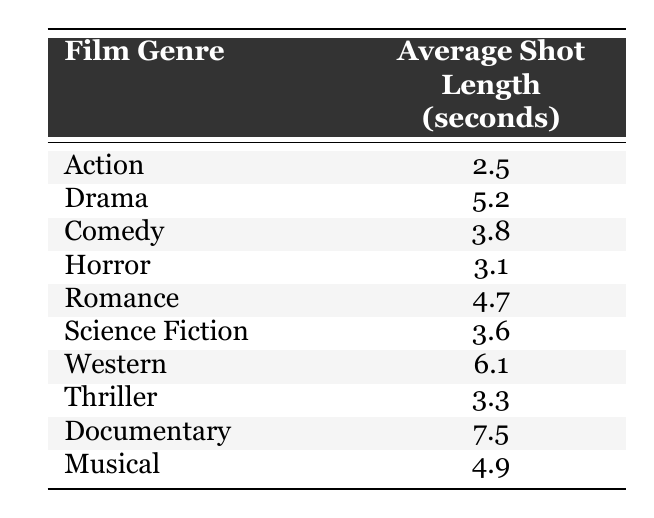What is the average shot length for the Action genre? The table lists Action with an average shot length of 2.5 seconds. This is a direct retrieval of the value from the table.
Answer: 2.5 Which film genre has the longest average shot length? The table indicates that the Documentary genre has the longest average shot length at 7.5 seconds. This can be found by comparing all the values in the second column to find the maximum.
Answer: 7.5 Is the average shot length for Comedy longer than that for Horror? The table shows that Comedy has an average shot length of 3.8 seconds while Horror has 3.1 seconds. Since 3.8 is greater than 3.1, the statement is true.
Answer: Yes What is the average shot length of the Romance and Science Fiction genres combined? To find the combined average, we first sum the average shot lengths for both genres: 4.7 (Romance) + 3.6 (Science Fiction) = 8.3 seconds. There are 2 genres, so we divide the sum by 2: 8.3/2 = 4.15 seconds.
Answer: 4.15 Is it true that the Thriller genre has an average shot length shorter than 4 seconds? The table states that the average shot length for Thriller is 3.3 seconds, which is indeed shorter than 4. This confirms that the statement is true.
Answer: Yes What is the difference in average shot length between the Action and Drama genres? The average shot length for Action is 2.5 seconds and for Drama, it is 5.2 seconds. To find the difference, we subtract: 5.2 - 2.5 = 2.7 seconds.
Answer: 2.7 How many genres have average shot lengths greater than 4 seconds? From the table, we see that Drama (5.2), Romance (4.7), Western (6.1), Documentary (7.5), and Musical (4.9) all have averages greater than 4 seconds, making a total of 5 genres.
Answer: 5 Which genres have an average shot length of less than 4 seconds? The table lists Horror (3.1), Action (2.5), and Thriller (3.3) as having average shot lengths of less than 4 seconds. These can be easily identified by checking all values below 4 seconds.
Answer: Horror, Action, Thriller What is the median average shot length of all the genres listed? To find the median, we first list all the average shot lengths in order: 2.5, 3.1, 3.3, 3.6, 3.8, 4.7, 4.9, 5.2, 6.1, 7.5. There are 10 data points, so the median is the average of the 5th and 6th values: (4.7 + 4.9)/2 = 4.8 seconds.
Answer: 4.8 